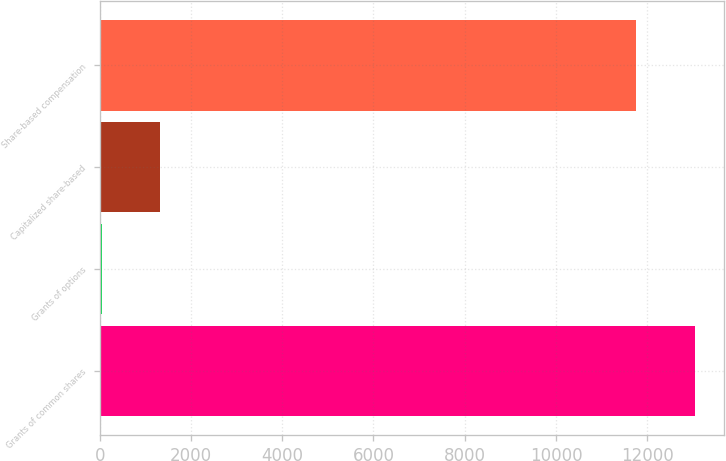<chart> <loc_0><loc_0><loc_500><loc_500><bar_chart><fcel>Grants of common shares<fcel>Grants of options<fcel>Capitalized share-based<fcel>Share-based compensation<nl><fcel>13037.3<fcel>49<fcel>1333.3<fcel>11753<nl></chart> 